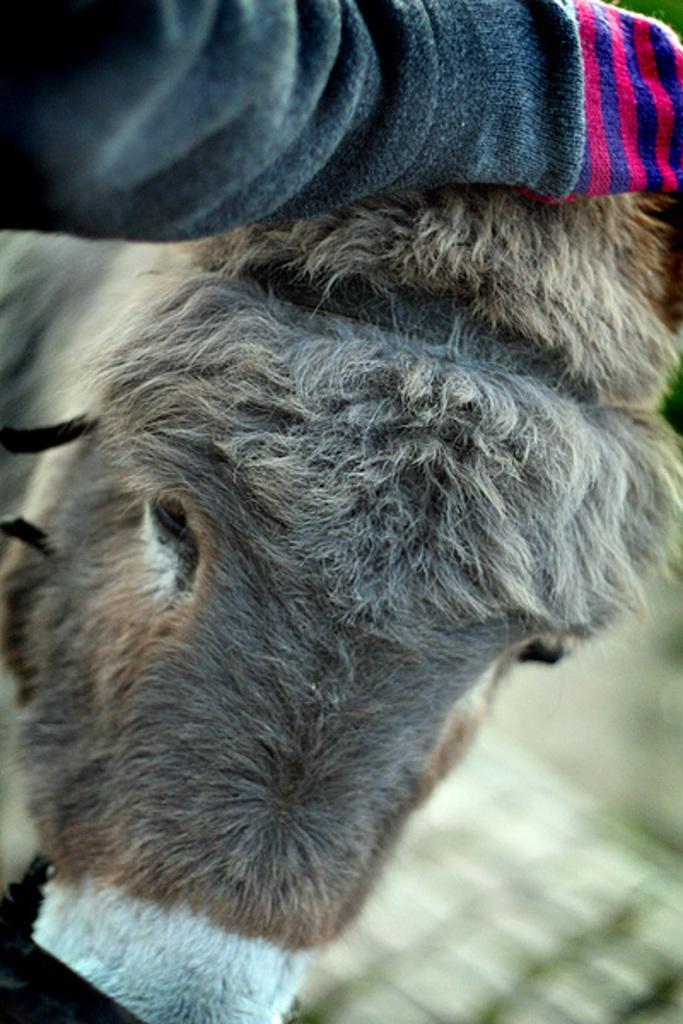Describe this image in one or two sentences. This is a donkey. 